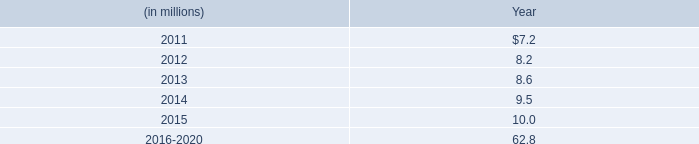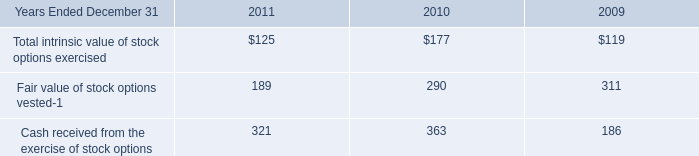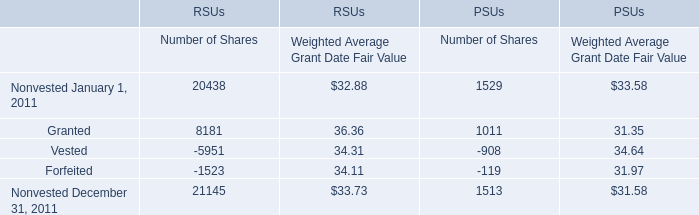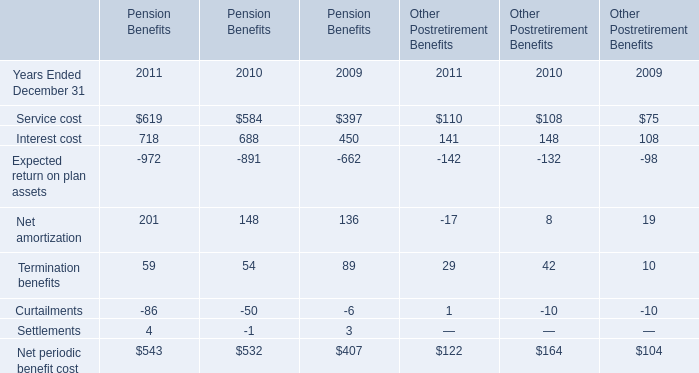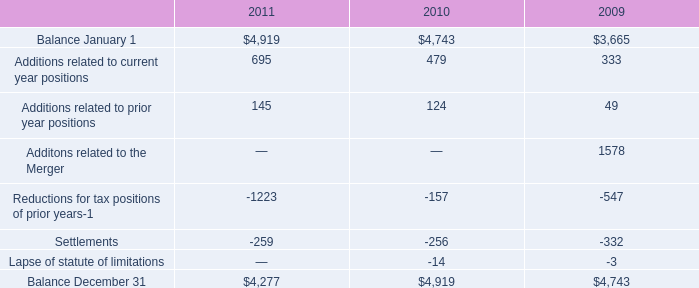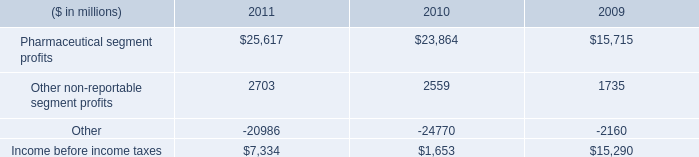If RSUs develops with the same growth rate in 2011, what will it reach in 2012? 
Computations: (((((21145 * 33.73) - (20438 * 32.88)) / (20438 * 32.88)) + 1) * (21145 * 33.73))
Answer: 756968.58756. 